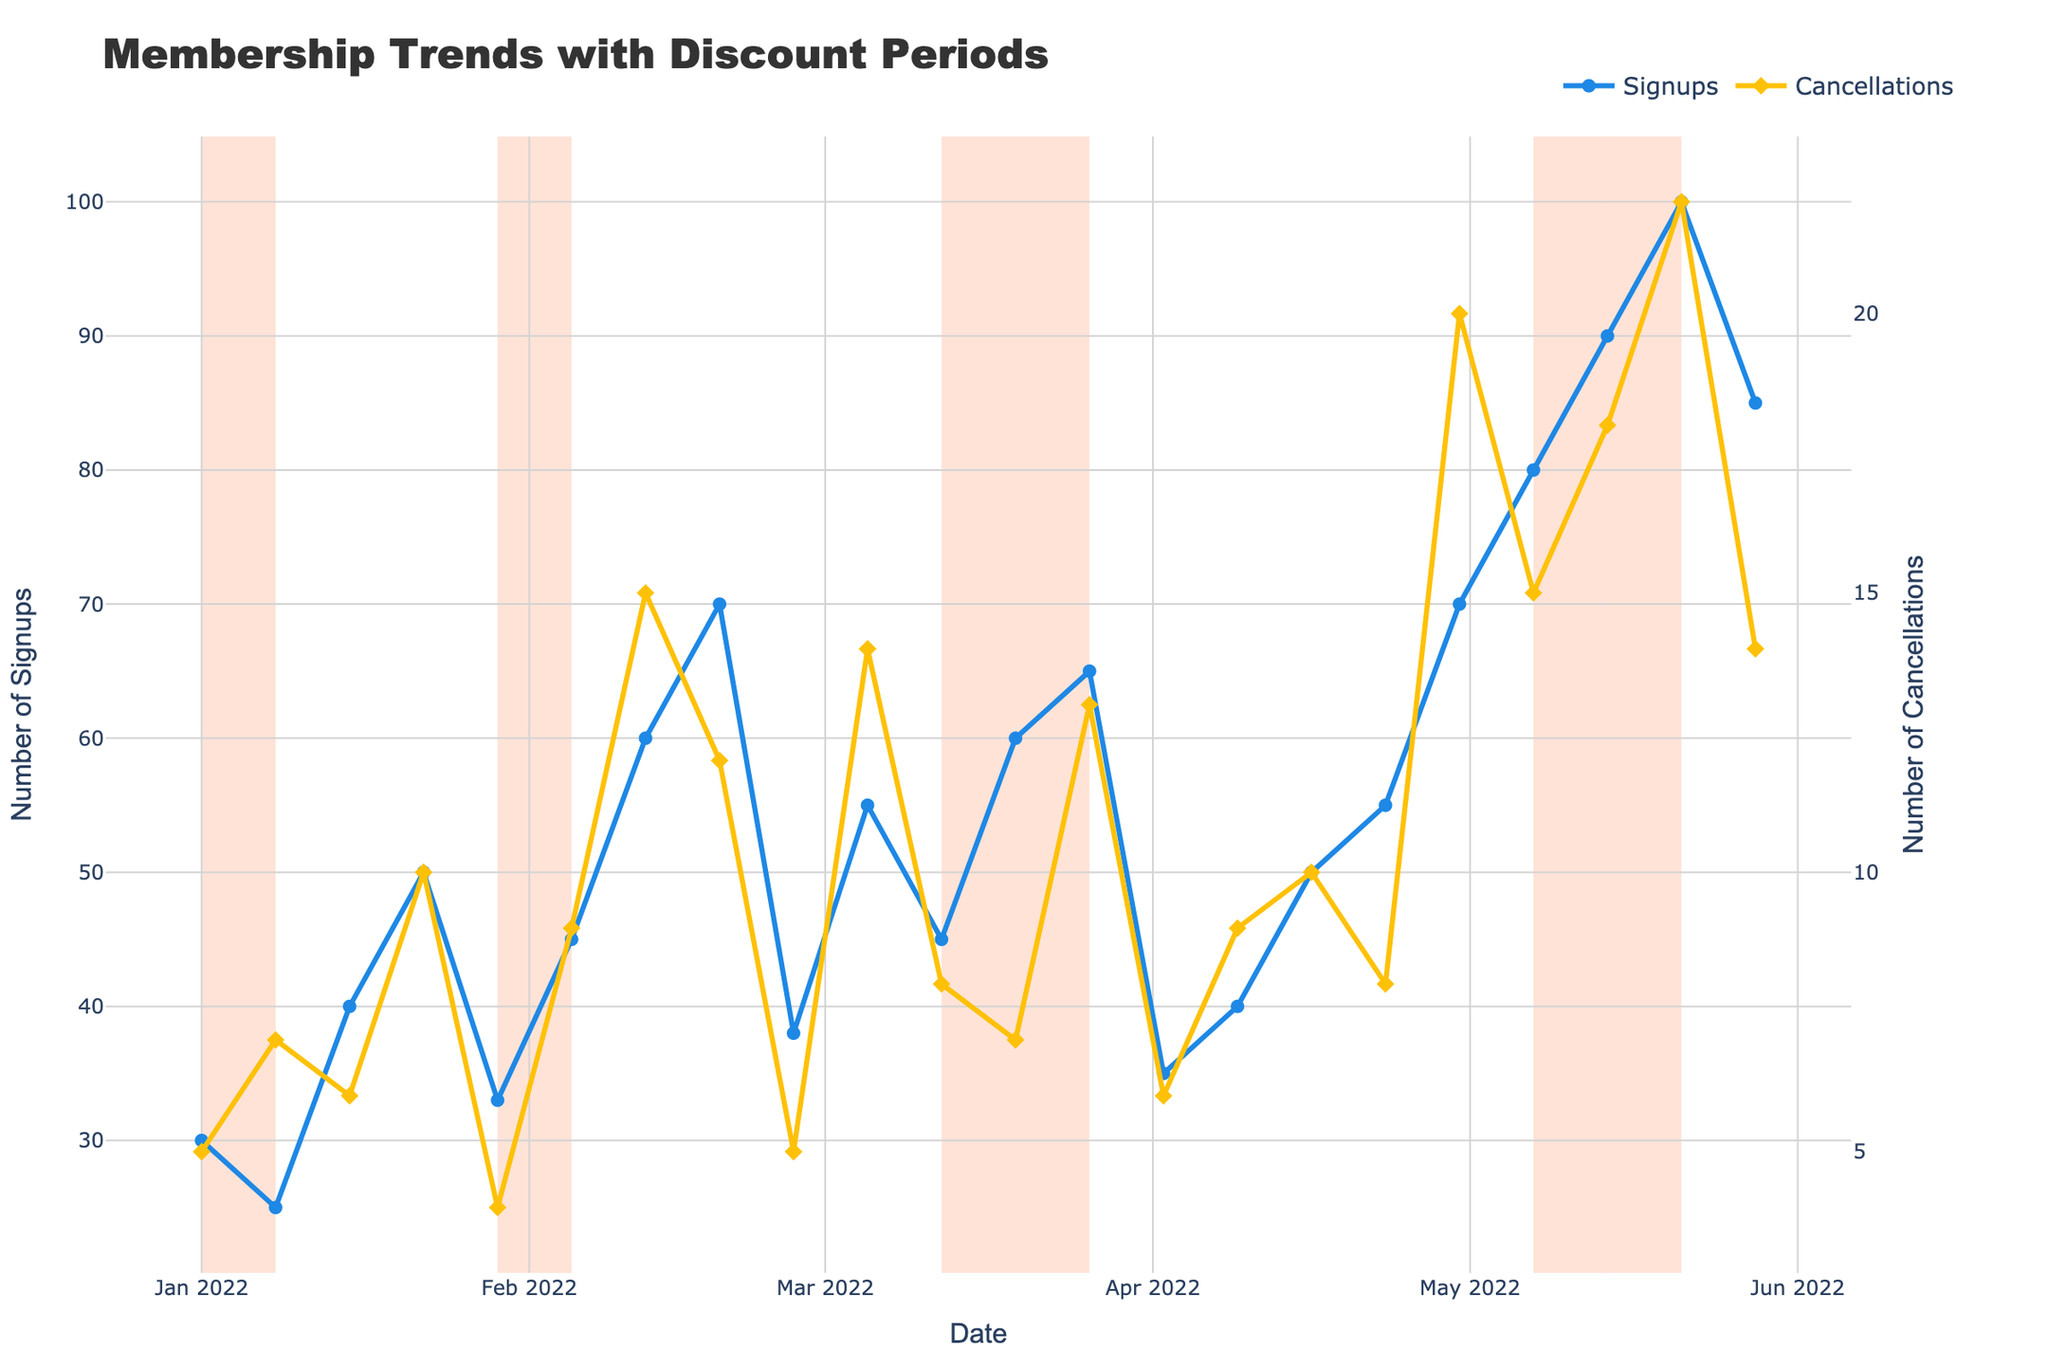What is the title of the figure? The title is typically located at the top of the figure and provides a summary of what the plot is about. Here, the title is displayed prominently in a larger font.
Answer: Membership Trends with Discount Periods How many times do discount periods appear on the plot? Discount periods are marked by vertical shaded regions. By counting the number of these shaded regions, we can determine the number of discount periods.
Answer: 5 Which date had the highest number of membership sign-ups? By identifying the peak value on the 'Signups' line and noting the corresponding date, we can find the date with the highest number of membership sign-ups.
Answer: 2022-05-21 How many membership cancellations occurred during the week of February 12, 2022? Locate the point on the 'Cancellations' line corresponding to the date of February 12, 2022, and read the value.
Answer: 15 Was there a discount period in the month of February 2022? Discount periods are marked by shaded regions. By looking through February, we can check if there are any shaded regions.
Answer: No What is the difference between the highest number of sign-ups and the lowest number of cancellations? Identify the peak value of sign-ups and the lowest value of cancellations from the plot, then subtract the lowest cancellations from the highest sign-ups.
Answer: 100 - 4 = 96 Are there more membership sign-ups or cancellations on January 15, 2022? Observe the values for both sign-ups and cancellations on the date of January 15, 2022, and compare them directly.
Answer: Sign-ups By how much did membership sign-ups increase from January 8 to January 15, 2022? Note the value of sign-ups on January 8 and subtract it from the value on January 15 to find the increase.
Answer: 40 - 25 = 15 Did any discount periods result in a decrease in cancellations compared to the week before? Check each discount period for cancellations and compare with the week prior to see if there is any decrease.
Answer: Yes Which month saw the highest cumulative membership cancellations? Sum the values of cancellations for each month individually, then identify the month with the highest sum.
Answer: May 